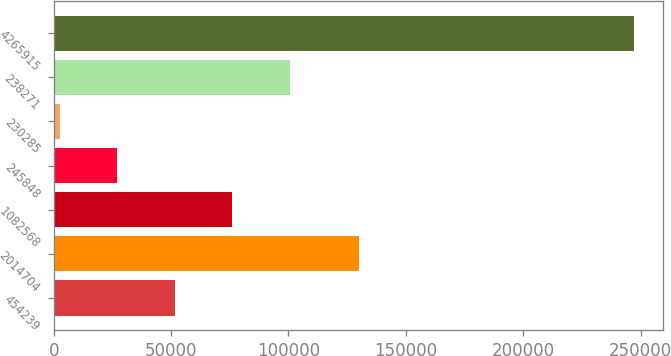Convert chart. <chart><loc_0><loc_0><loc_500><loc_500><bar_chart><fcel>454239<fcel>2014704<fcel>1082568<fcel>245848<fcel>230285<fcel>238271<fcel>4265915<nl><fcel>51608.8<fcel>129940<fcel>76040.2<fcel>27177.4<fcel>2746<fcel>100472<fcel>247060<nl></chart> 